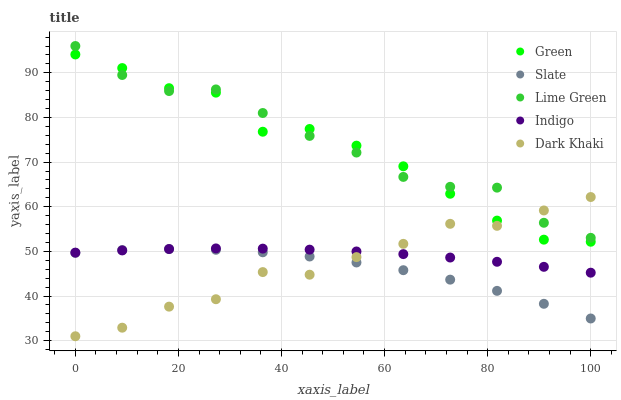Does Slate have the minimum area under the curve?
Answer yes or no. Yes. Does Lime Green have the maximum area under the curve?
Answer yes or no. Yes. Does Lime Green have the minimum area under the curve?
Answer yes or no. No. Does Slate have the maximum area under the curve?
Answer yes or no. No. Is Indigo the smoothest?
Answer yes or no. Yes. Is Green the roughest?
Answer yes or no. Yes. Is Lime Green the smoothest?
Answer yes or no. No. Is Lime Green the roughest?
Answer yes or no. No. Does Dark Khaki have the lowest value?
Answer yes or no. Yes. Does Slate have the lowest value?
Answer yes or no. No. Does Lime Green have the highest value?
Answer yes or no. Yes. Does Slate have the highest value?
Answer yes or no. No. Is Slate less than Lime Green?
Answer yes or no. Yes. Is Green greater than Slate?
Answer yes or no. Yes. Does Lime Green intersect Green?
Answer yes or no. Yes. Is Lime Green less than Green?
Answer yes or no. No. Is Lime Green greater than Green?
Answer yes or no. No. Does Slate intersect Lime Green?
Answer yes or no. No. 